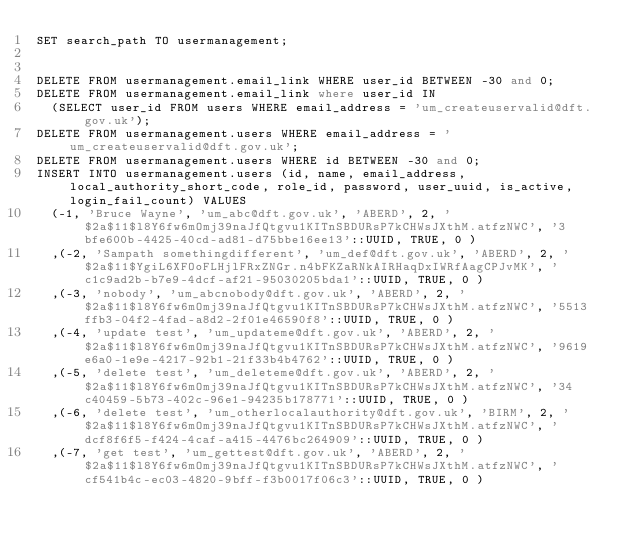<code> <loc_0><loc_0><loc_500><loc_500><_SQL_>SET search_path TO usermanagement;


DELETE FROM usermanagement.email_link WHERE user_id BETWEEN -30 and 0;
DELETE FROM usermanagement.email_link where user_id IN
  (SELECT user_id FROM users WHERE email_address = 'um_createuservalid@dft.gov.uk');
DELETE FROM usermanagement.users WHERE email_address = 'um_createuservalid@dft.gov.uk';
DELETE FROM usermanagement.users WHERE id BETWEEN -30 and 0;
INSERT INTO usermanagement.users (id, name, email_address, local_authority_short_code, role_id, password, user_uuid, is_active, login_fail_count) VALUES
  (-1, 'Bruce Wayne', 'um_abc@dft.gov.uk', 'ABERD', 2, '$2a$11$l8Y6fw6mOmj39naJfQtgvu1KITnSBDURsP7kCHWsJXthM.atfzNWC', '3bfe600b-4425-40cd-ad81-d75bbe16ee13'::UUID, TRUE, 0 )
  ,(-2, 'Sampath somethingdifferent', 'um_def@dft.gov.uk', 'ABERD', 2, '$2a$11$YgiL6XFOoFLHjlFRxZNGr.n4bFKZaRNkAIRHaqDxIWRfAagCPJvMK', 'c1c9ad2b-b7e9-4dcf-af21-95030205bda1'::UUID, TRUE, 0 )
  ,(-3, 'nobody', 'um_abcnobody@dft.gov.uk', 'ABERD', 2, '$2a$11$l8Y6fw6mOmj39naJfQtgvu1KITnSBDURsP7kCHWsJXthM.atfzNWC', '5513ffb3-04f2-4fad-a8d2-2f01e46590f8'::UUID, TRUE, 0 )
  ,(-4, 'update test', 'um_updateme@dft.gov.uk', 'ABERD', 2, '$2a$11$l8Y6fw6mOmj39naJfQtgvu1KITnSBDURsP7kCHWsJXthM.atfzNWC', '9619e6a0-1e9e-4217-92b1-21f33b4b4762'::UUID, TRUE, 0 )
  ,(-5, 'delete test', 'um_deleteme@dft.gov.uk', 'ABERD', 2, '$2a$11$l8Y6fw6mOmj39naJfQtgvu1KITnSBDURsP7kCHWsJXthM.atfzNWC', '34c40459-5b73-402c-96e1-94235b178771'::UUID, TRUE, 0 )
  ,(-6, 'delete test', 'um_otherlocalauthority@dft.gov.uk', 'BIRM', 2, '$2a$11$l8Y6fw6mOmj39naJfQtgvu1KITnSBDURsP7kCHWsJXthM.atfzNWC', 'dcf8f6f5-f424-4caf-a415-4476bc264909'::UUID, TRUE, 0 )
  ,(-7, 'get test', 'um_gettest@dft.gov.uk', 'ABERD', 2, '$2a$11$l8Y6fw6mOmj39naJfQtgvu1KITnSBDURsP7kCHWsJXthM.atfzNWC', 'cf541b4c-ec03-4820-9bff-f3b0017f06c3'::UUID, TRUE, 0 )</code> 